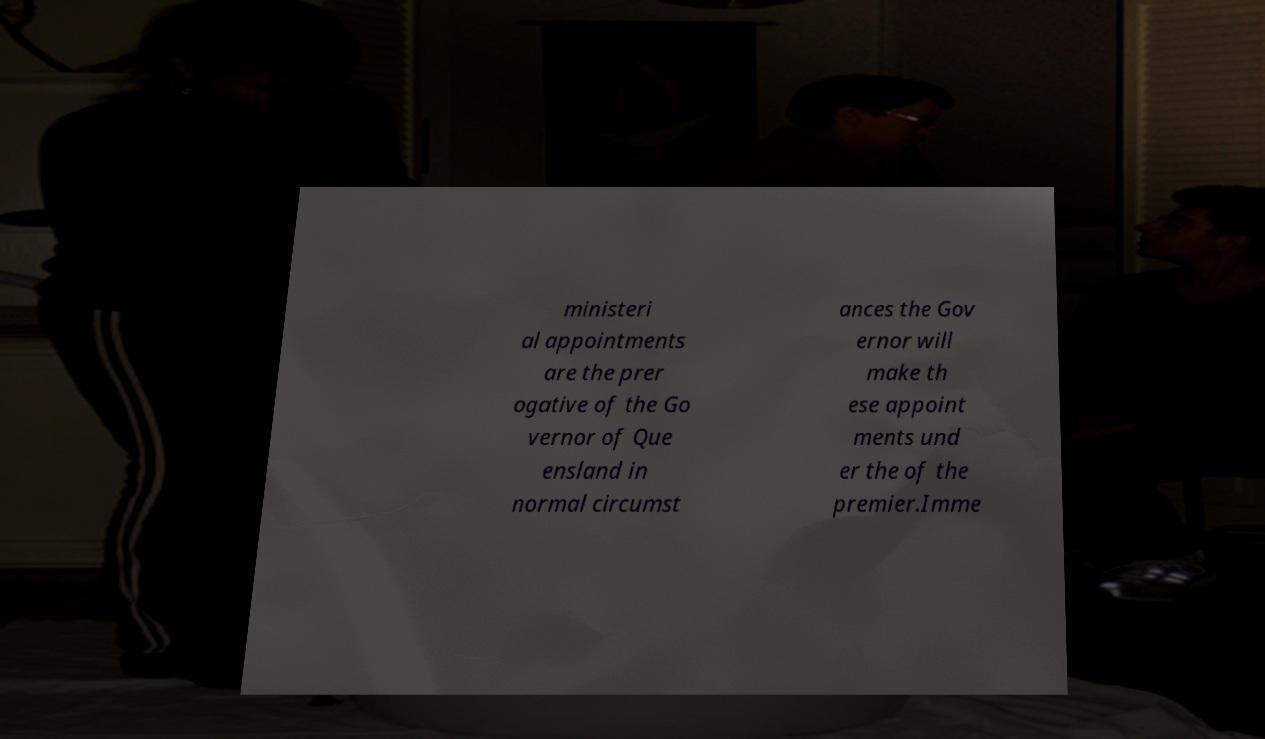There's text embedded in this image that I need extracted. Can you transcribe it verbatim? ministeri al appointments are the prer ogative of the Go vernor of Que ensland in normal circumst ances the Gov ernor will make th ese appoint ments und er the of the premier.Imme 